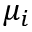Convert formula to latex. <formula><loc_0><loc_0><loc_500><loc_500>\mu _ { i }</formula> 